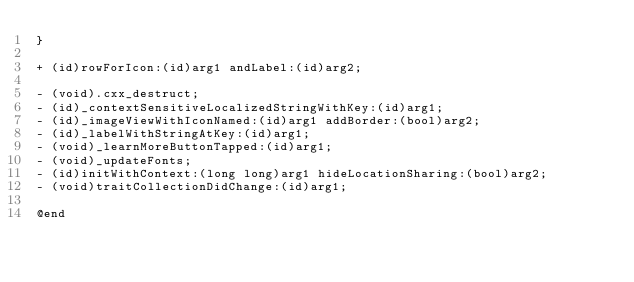<code> <loc_0><loc_0><loc_500><loc_500><_C_>}

+ (id)rowForIcon:(id)arg1 andLabel:(id)arg2;

- (void).cxx_destruct;
- (id)_contextSensitiveLocalizedStringWithKey:(id)arg1;
- (id)_imageViewWithIconNamed:(id)arg1 addBorder:(bool)arg2;
- (id)_labelWithStringAtKey:(id)arg1;
- (void)_learnMoreButtonTapped:(id)arg1;
- (void)_updateFonts;
- (id)initWithContext:(long long)arg1 hideLocationSharing:(bool)arg2;
- (void)traitCollectionDidChange:(id)arg1;

@end
</code> 